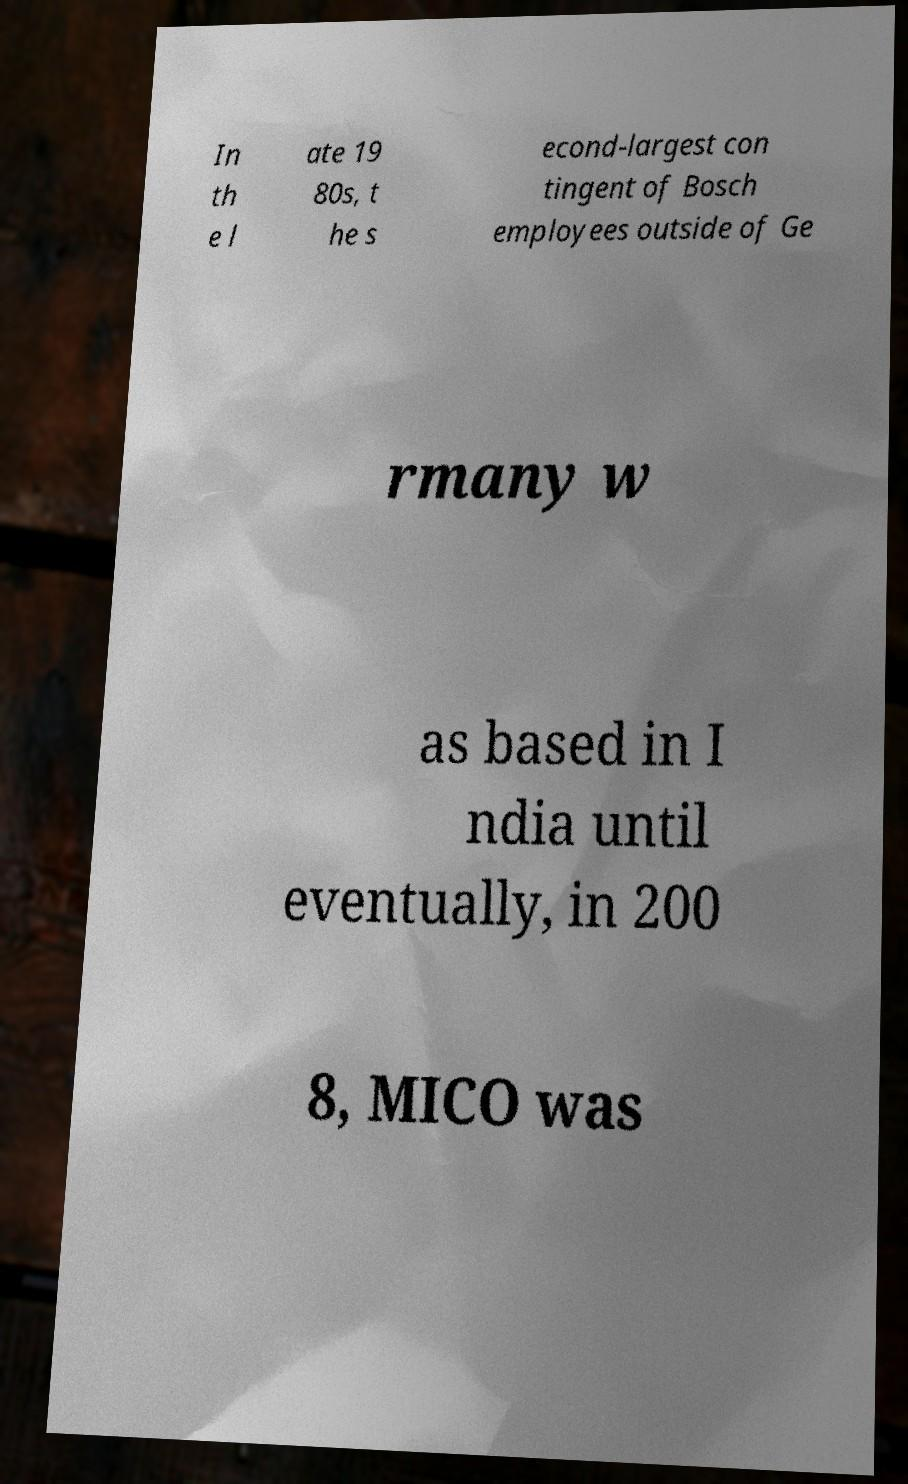What messages or text are displayed in this image? I need them in a readable, typed format. In th e l ate 19 80s, t he s econd-largest con tingent of Bosch employees outside of Ge rmany w as based in I ndia until eventually, in 200 8, MICO was 